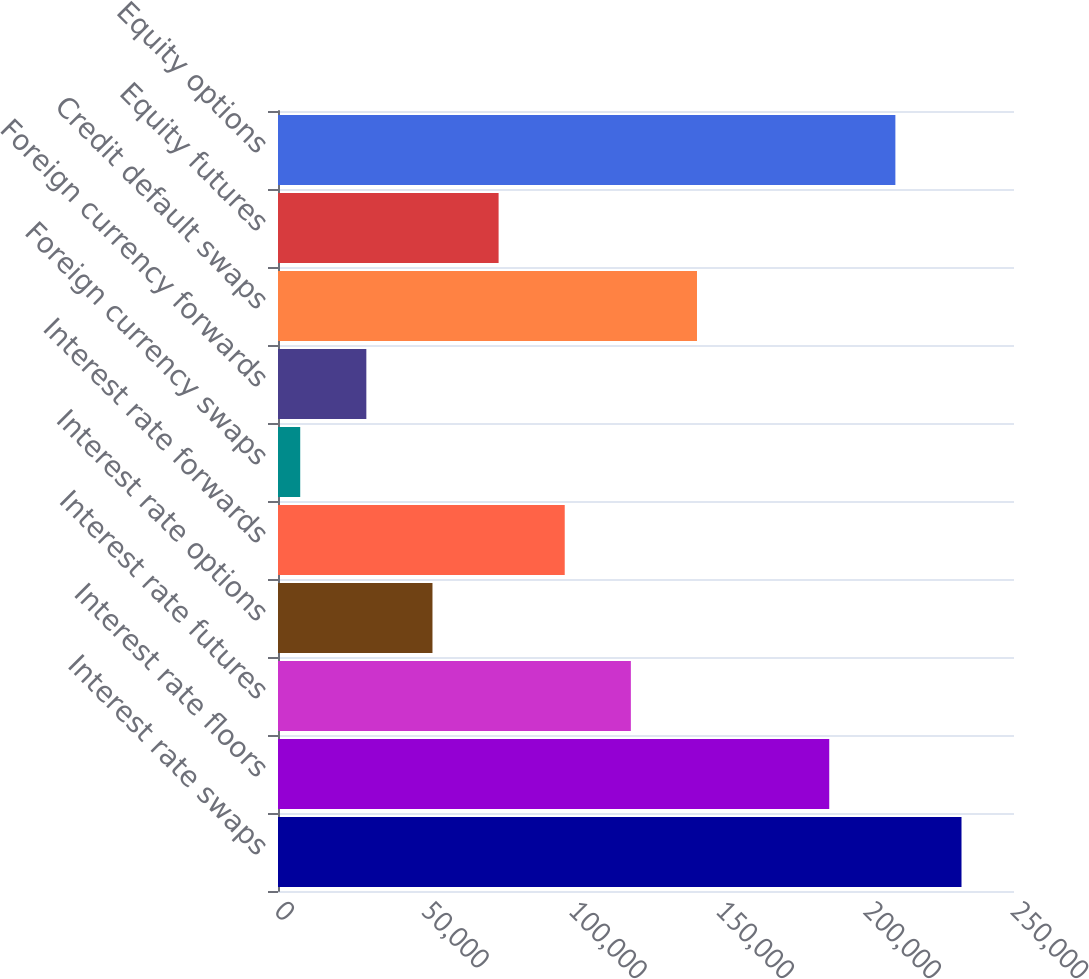<chart> <loc_0><loc_0><loc_500><loc_500><bar_chart><fcel>Interest rate swaps<fcel>Interest rate floors<fcel>Interest rate futures<fcel>Interest rate options<fcel>Interest rate forwards<fcel>Foreign currency swaps<fcel>Foreign currency forwards<fcel>Credit default swaps<fcel>Equity futures<fcel>Equity options<nl><fcel>232169<fcel>187244<fcel>119858<fcel>52470.6<fcel>97395.2<fcel>7546<fcel>30008.3<fcel>142320<fcel>74932.9<fcel>209707<nl></chart> 